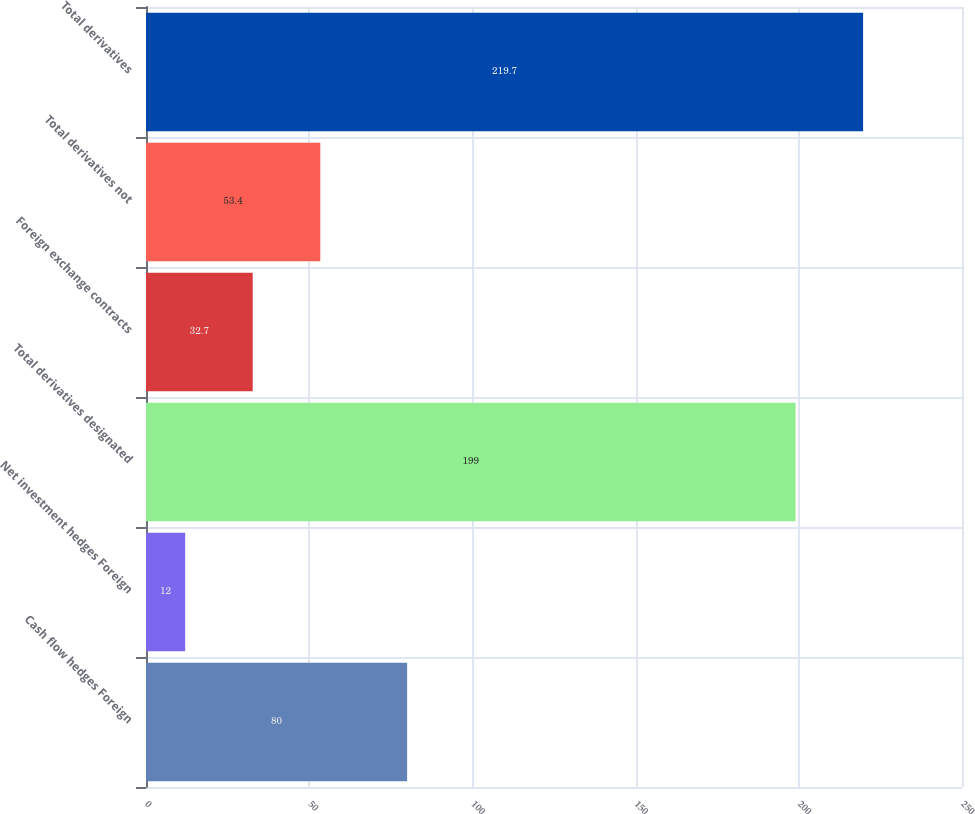<chart> <loc_0><loc_0><loc_500><loc_500><bar_chart><fcel>Cash flow hedges Foreign<fcel>Net investment hedges Foreign<fcel>Total derivatives designated<fcel>Foreign exchange contracts<fcel>Total derivatives not<fcel>Total derivatives<nl><fcel>80<fcel>12<fcel>199<fcel>32.7<fcel>53.4<fcel>219.7<nl></chart> 